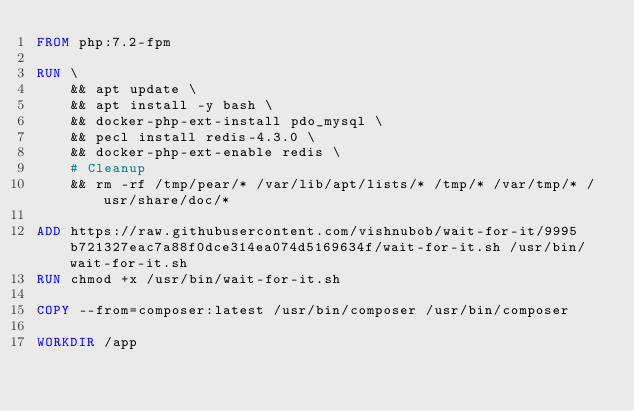<code> <loc_0><loc_0><loc_500><loc_500><_Dockerfile_>FROM php:7.2-fpm

RUN \
    && apt update \
    && apt install -y bash \
    && docker-php-ext-install pdo_mysql \
    && pecl install redis-4.3.0 \
    && docker-php-ext-enable redis \
    # Cleanup
    && rm -rf /tmp/pear/* /var/lib/apt/lists/* /tmp/* /var/tmp/* /usr/share/doc/*

ADD https://raw.githubusercontent.com/vishnubob/wait-for-it/9995b721327eac7a88f0dce314ea074d5169634f/wait-for-it.sh /usr/bin/wait-for-it.sh
RUN chmod +x /usr/bin/wait-for-it.sh

COPY --from=composer:latest /usr/bin/composer /usr/bin/composer

WORKDIR /app
</code> 